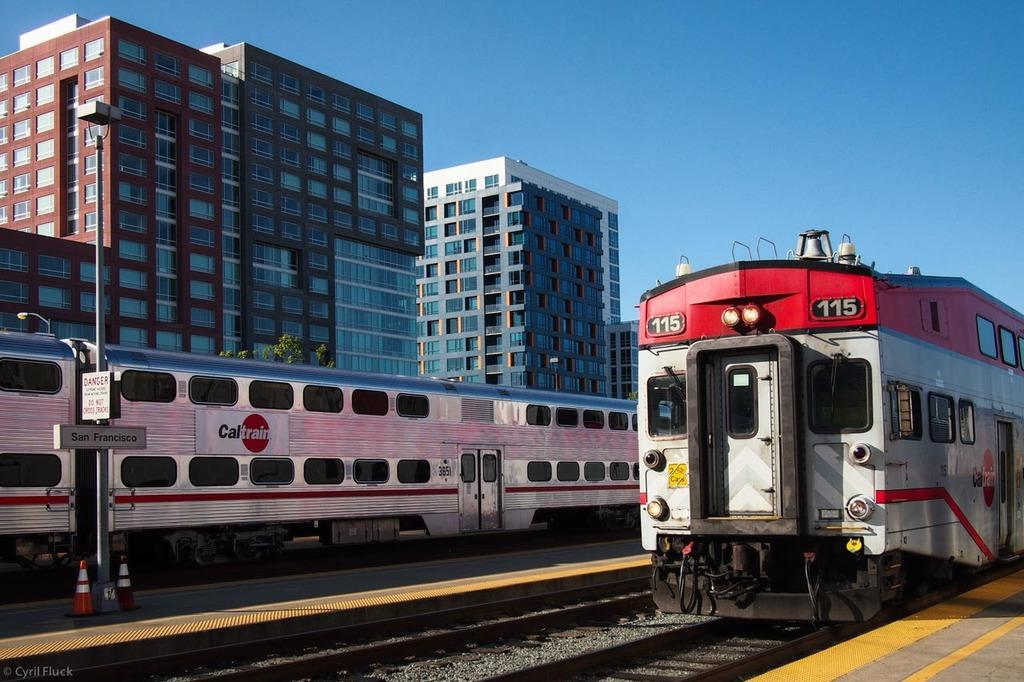What type of vehicles can be seen on the railway tracks in the image? There are trains on the railway tracks in the image. What is attached to the pole in the image? There are boards on the pole in the image. What safety equipment is present in the image? Traffic cones are present in the image. What structures are visible for passengers to wait on? Platforms are visible in the image. What type of vegetation is present in the image? Trees are in the image. What can be seen in the background of the image? There are buildings, windows, and the sky visible in the background. Can you see a worm crawling on the train in the image? There is no worm present in the image. What color is the orange that is being peeled on the platform? There is no orange present in the image. 